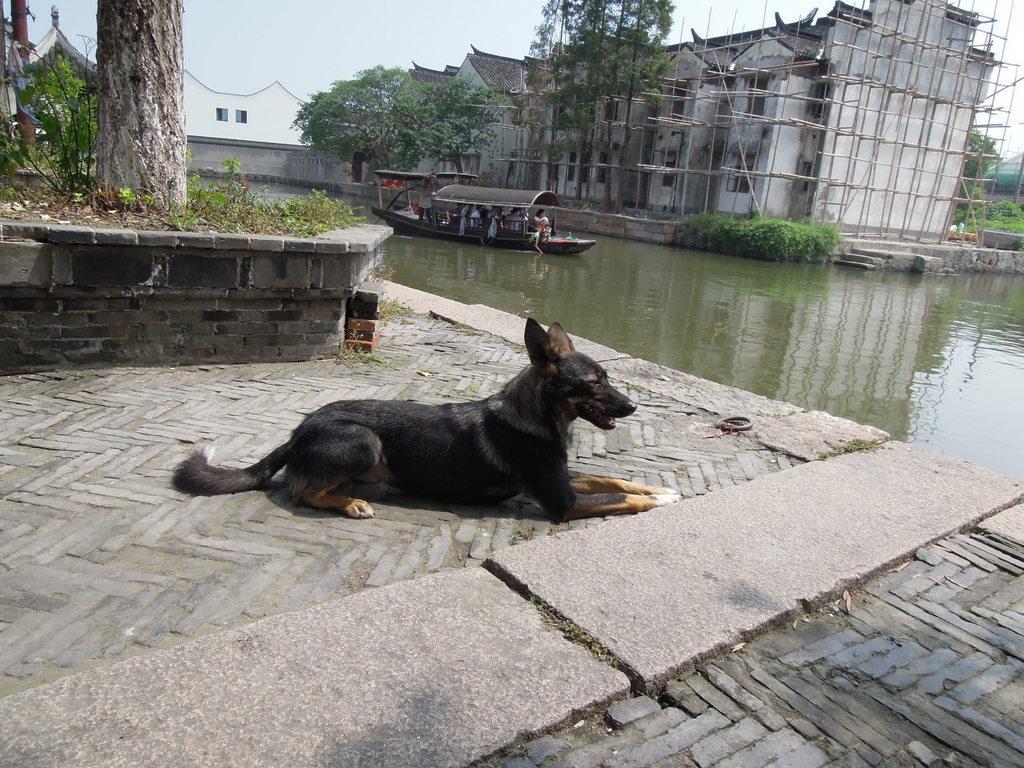Could you give a brief overview of what you see in this image? Front a dog is sitting on this ground. On this water there is a boat with people. Background there is a building, plants and trees.  